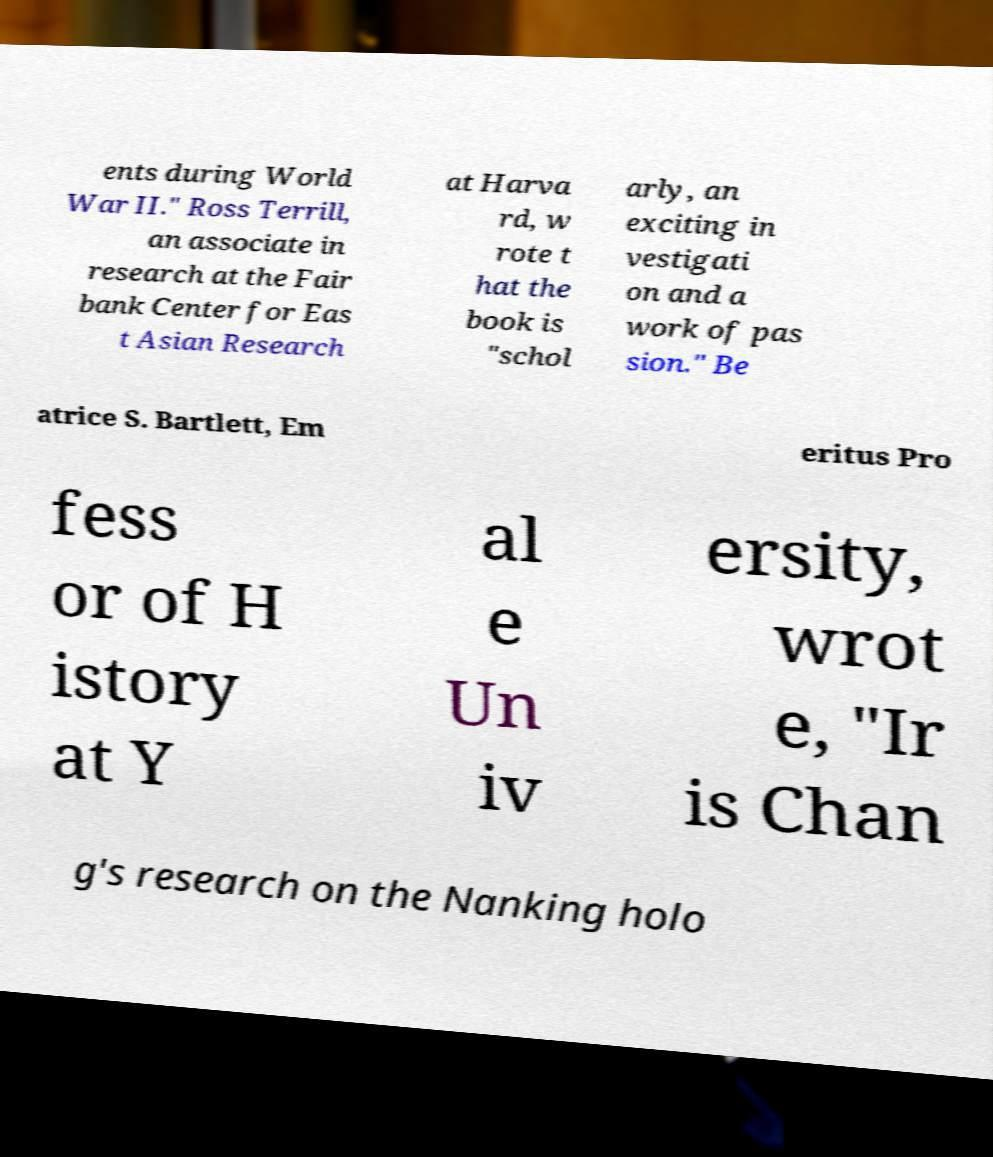Could you assist in decoding the text presented in this image and type it out clearly? ents during World War II." Ross Terrill, an associate in research at the Fair bank Center for Eas t Asian Research at Harva rd, w rote t hat the book is "schol arly, an exciting in vestigati on and a work of pas sion." Be atrice S. Bartlett, Em eritus Pro fess or of H istory at Y al e Un iv ersity, wrot e, "Ir is Chan g's research on the Nanking holo 